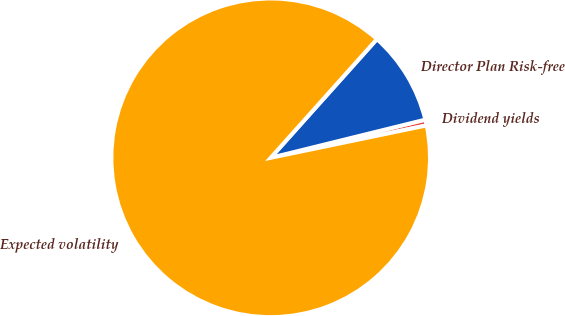<chart> <loc_0><loc_0><loc_500><loc_500><pie_chart><fcel>Dividend yields<fcel>Director Plan Risk-free<fcel>Expected volatility<nl><fcel>0.59%<fcel>9.53%<fcel>89.88%<nl></chart> 